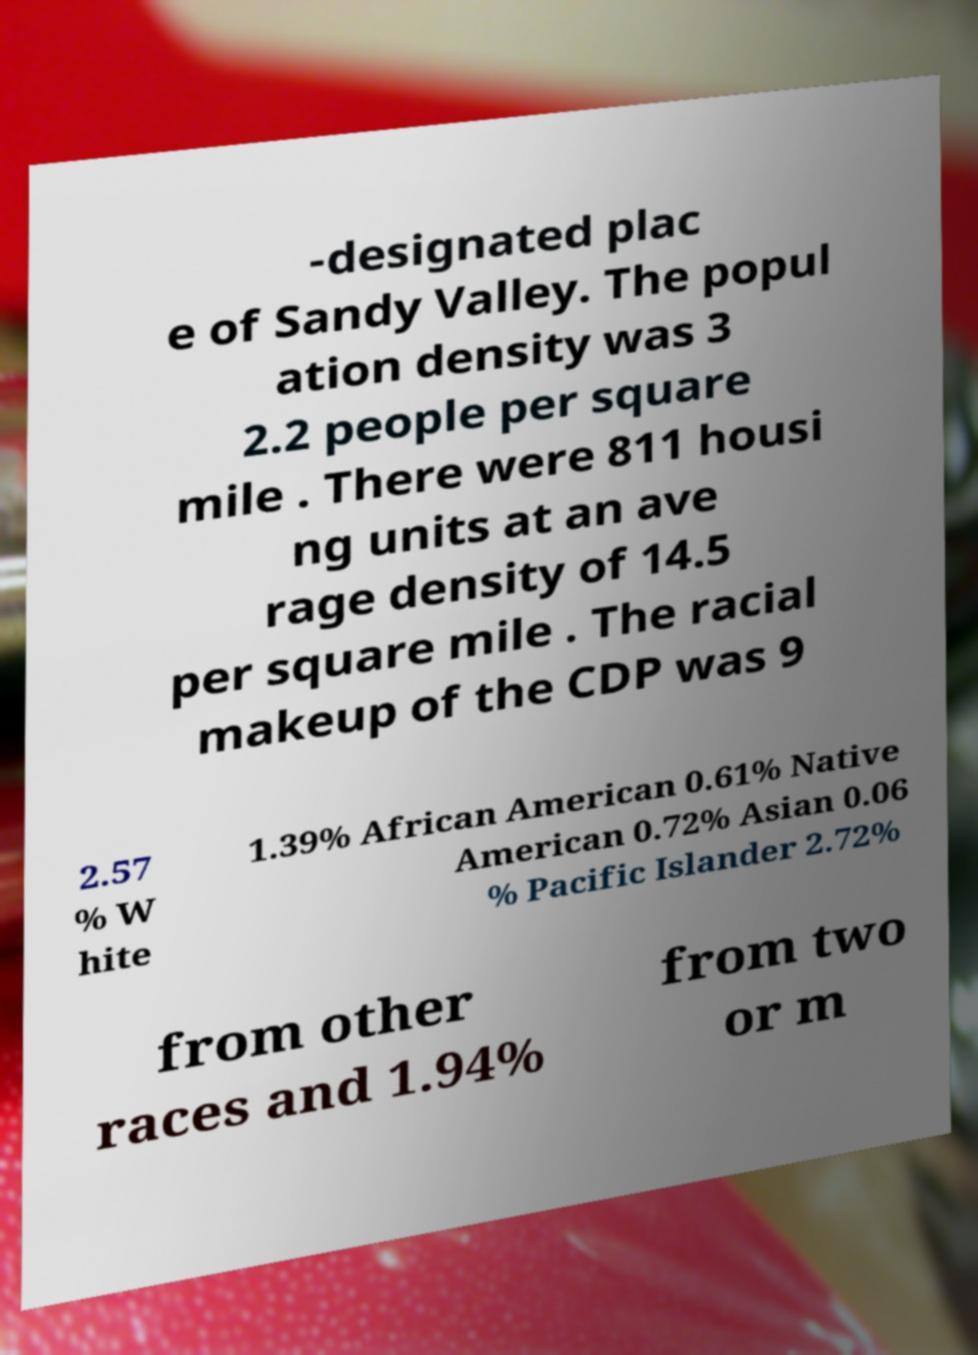Please read and relay the text visible in this image. What does it say? -designated plac e of Sandy Valley. The popul ation density was 3 2.2 people per square mile . There were 811 housi ng units at an ave rage density of 14.5 per square mile . The racial makeup of the CDP was 9 2.57 % W hite 1.39% African American 0.61% Native American 0.72% Asian 0.06 % Pacific Islander 2.72% from other races and 1.94% from two or m 